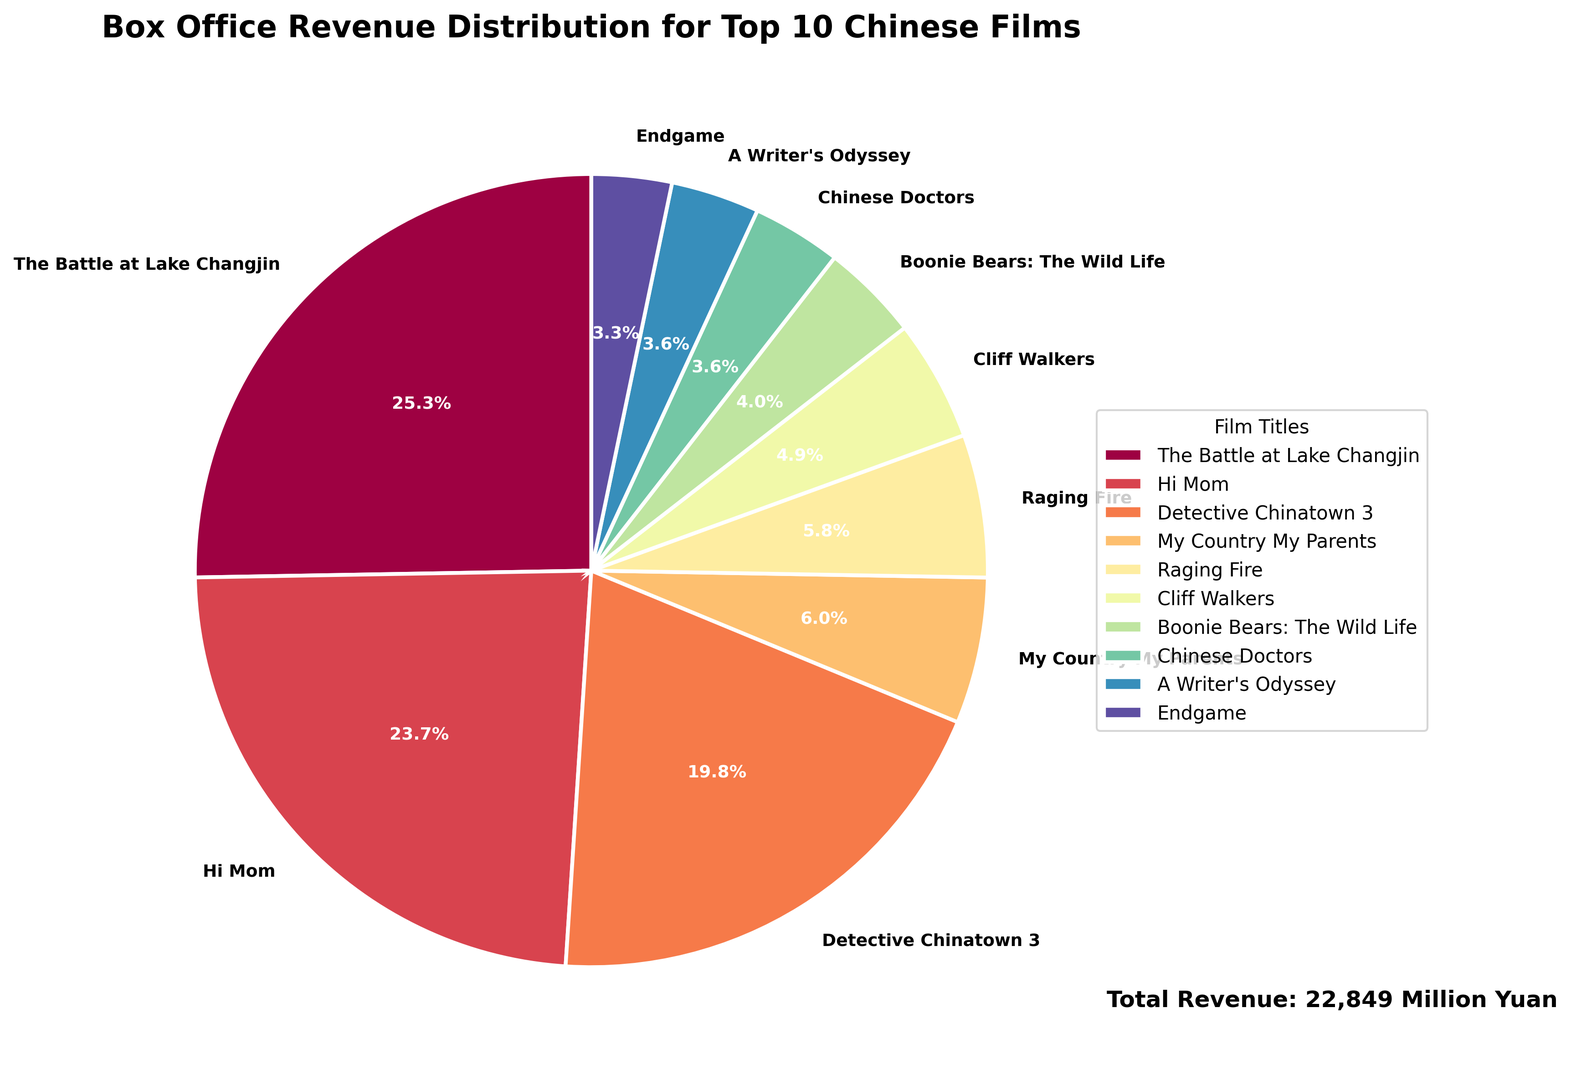Which film had the highest box office revenue? In the pie chart, identify the film with the largest slice. "The Battle at Lake Changjin" has the largest slice.
Answer: The Battle at Lake Changjin Which film had the lowest box office revenue? Identify the film with the smallest slice in the pie chart. The smallest slice belongs to "Endgame".
Answer: Endgame What percentage of the total box office revenue does "Hi Mom" account for? Look at the percentage given in the pie chart for "Hi Mom". "Hi Mom" accounts for 21.6% of the total box office revenue.
Answer: 21.6% How much more revenue did "The Battle at Lake Changjin" generate compared to "Detective Chinatown 3"? Calculate the difference in their revenues: 5775 million - 4523 million. The difference is 1252 million yuan.
Answer: 1252 million yuan Which film has a larger box office percentage, "Raging Fire" or "My Country My Parents"? Compare the percentage of the slices for "Raging Fire" and "My Country My Parents". "Raging Fire" has a smaller slice than "My Country My Parents".
Answer: My Country My Parents What is the combined box office revenue of the three lowest grossing films? Sum the revenues of "Endgame", "A Writer's Odyssey", and "Chinese Doctors". 747 million + 825 million + 831 million = 2403 million yuan.
Answer: 2403 million yuan How does the revenue of "Cliff Walkers" compare to that of "Boonie Bears: The Wild Life"? Compare the two revenues: 1130 million yuan (Cliff Walkers) vs 912 million yuan (Boonie Bears: The Wild Life). "Cliff Walkers" generated more revenue.
Answer: Cliff Walkers How many films generated more than 1000 million yuan in box office revenue? Identify the films with slices that represent more than 1000 million yuan. Six films generated more than 1000 million yuan: "The Battle at Lake Changjin", "Hi Mom", "Detective Chinatown 3", "My Country My Parents", "Raging Fire", and "Cliff Walkers".
Answer: 6 What percentage of the total box office revenue do the top two films make up combined? Sum the percentages of "The Battle at Lake Changjin" and "Hi Mom". 23.7% + 21.6% = 45.3%.
Answer: 45.3% 